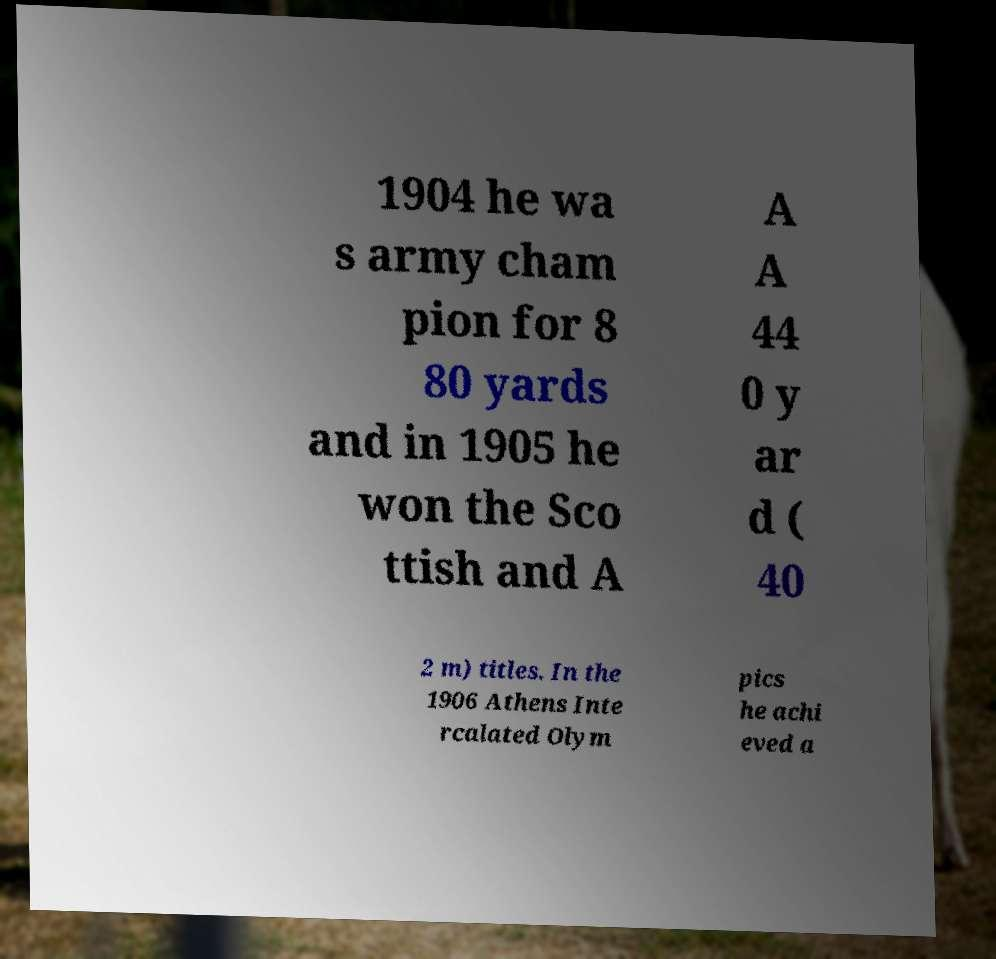Could you extract and type out the text from this image? 1904 he wa s army cham pion for 8 80 yards and in 1905 he won the Sco ttish and A A A 44 0 y ar d ( 40 2 m) titles. In the 1906 Athens Inte rcalated Olym pics he achi eved a 